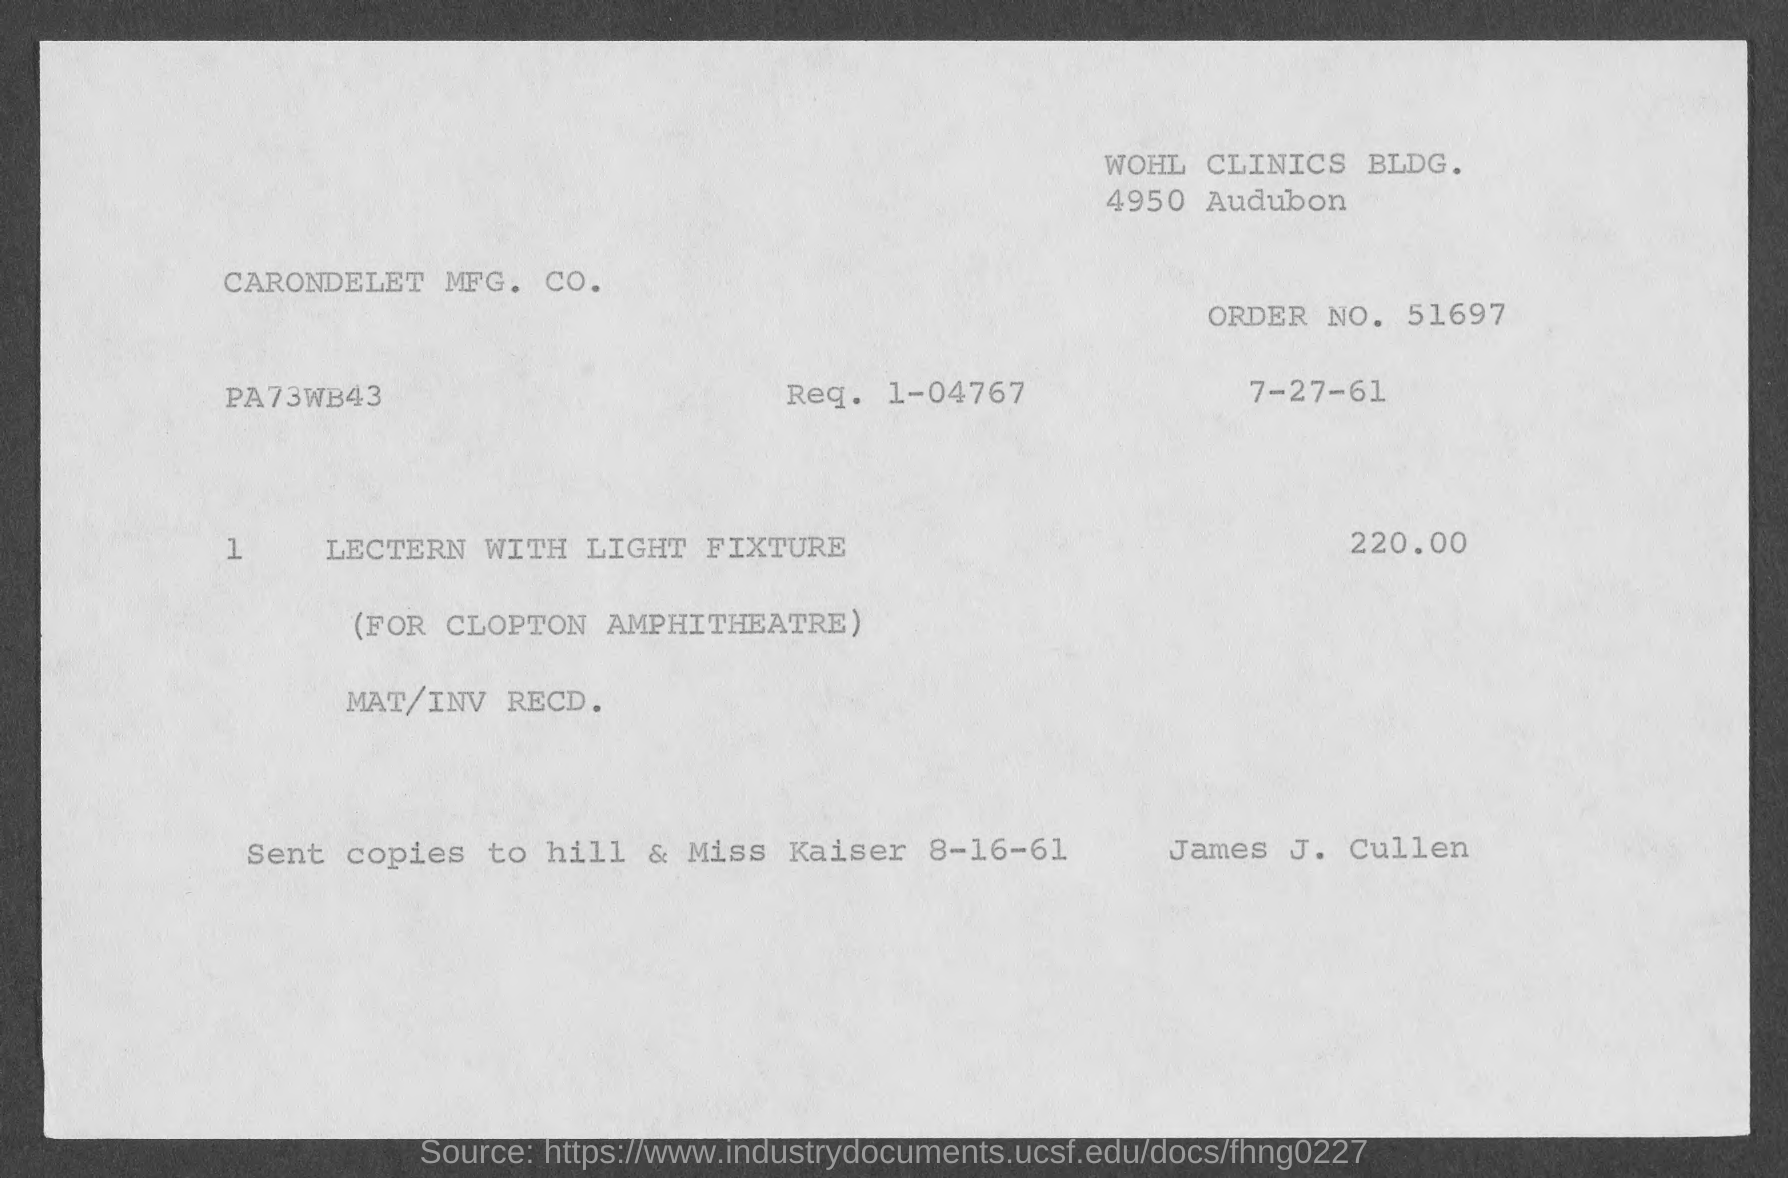Highlight a few significant elements in this photo. I am requesting information regarding the order number 51697... 